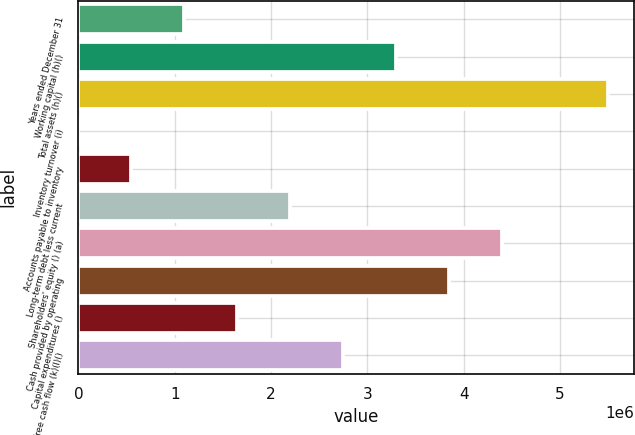Convert chart to OTSL. <chart><loc_0><loc_0><loc_500><loc_500><bar_chart><fcel>Years ended December 31<fcel>Working capital (h)()<fcel>Total assets (h)()<fcel>Inventory turnover (i)<fcel>Accounts payable to inventory<fcel>Long-term debt less current<fcel>Shareholders' equity () (a)<fcel>Cash provided by operating<fcel>Capital expenditures ()<fcel>Free cash flow (k)(l)()<nl><fcel>1.09884e+06<fcel>3.2965e+06<fcel>5.49417e+06<fcel>1.5<fcel>549419<fcel>2.19767e+06<fcel>4.39534e+06<fcel>3.84592e+06<fcel>1.64825e+06<fcel>2.74709e+06<nl></chart> 